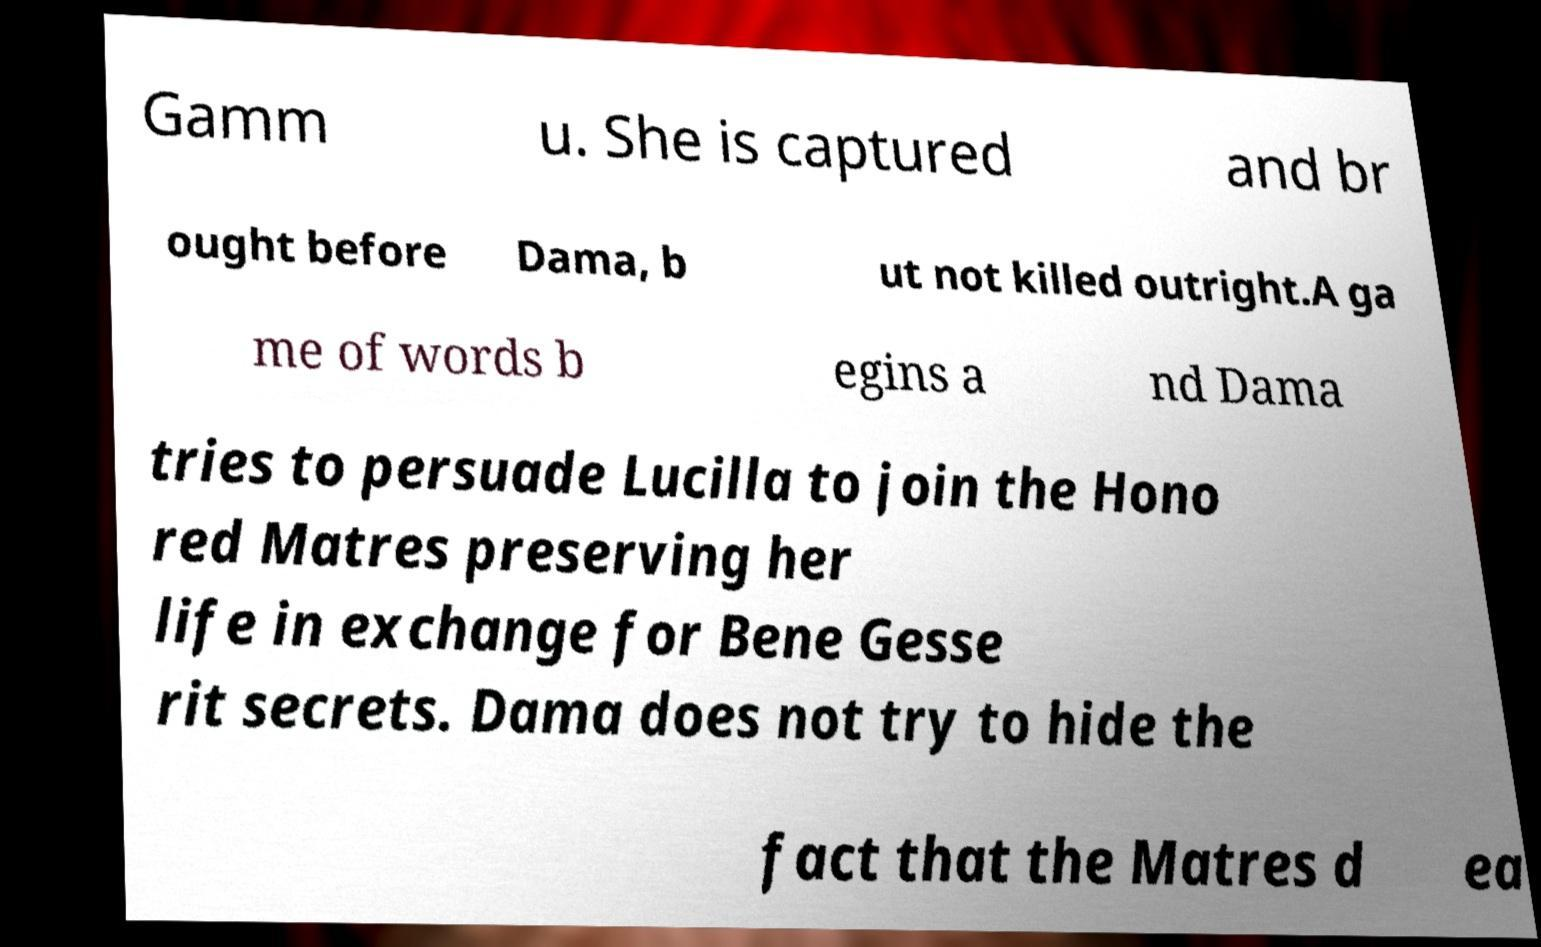Could you assist in decoding the text presented in this image and type it out clearly? Gamm u. She is captured and br ought before Dama, b ut not killed outright.A ga me of words b egins a nd Dama tries to persuade Lucilla to join the Hono red Matres preserving her life in exchange for Bene Gesse rit secrets. Dama does not try to hide the fact that the Matres d ea 